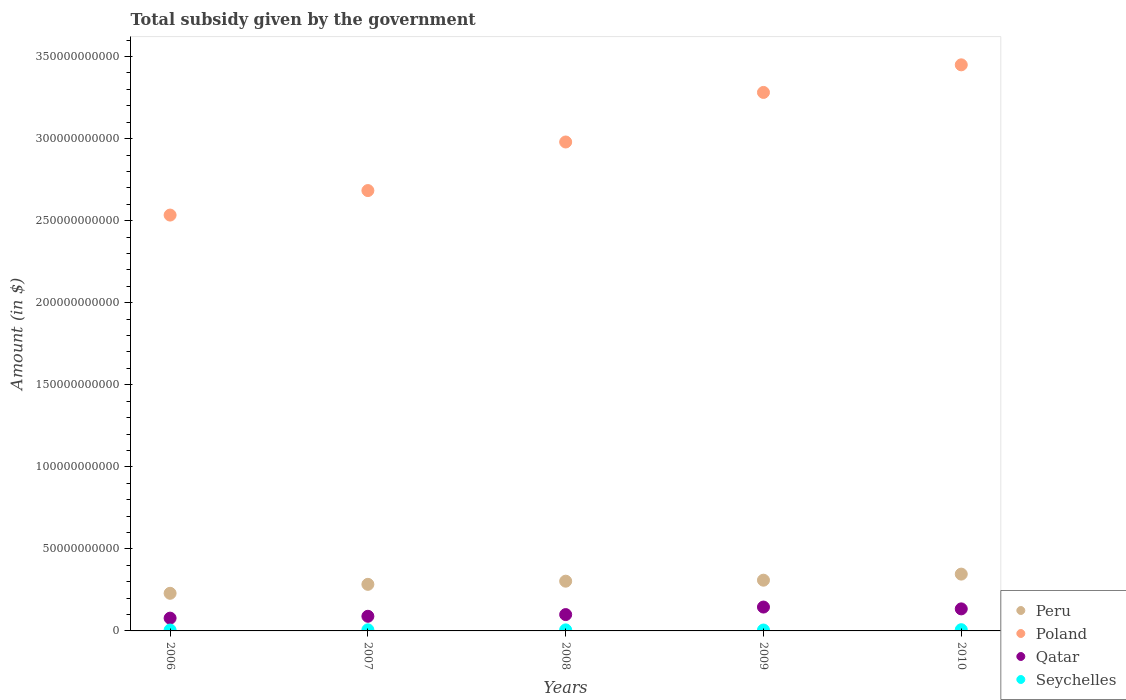How many different coloured dotlines are there?
Your response must be concise. 4. What is the total revenue collected by the government in Peru in 2007?
Your answer should be compact. 2.84e+1. Across all years, what is the maximum total revenue collected by the government in Qatar?
Your response must be concise. 1.45e+1. Across all years, what is the minimum total revenue collected by the government in Peru?
Ensure brevity in your answer.  2.29e+1. In which year was the total revenue collected by the government in Qatar minimum?
Provide a short and direct response. 2006. What is the total total revenue collected by the government in Poland in the graph?
Ensure brevity in your answer.  1.49e+12. What is the difference between the total revenue collected by the government in Peru in 2007 and that in 2010?
Give a very brief answer. -6.23e+09. What is the difference between the total revenue collected by the government in Qatar in 2010 and the total revenue collected by the government in Peru in 2007?
Keep it short and to the point. -1.50e+1. What is the average total revenue collected by the government in Seychelles per year?
Give a very brief answer. 6.26e+08. In the year 2007, what is the difference between the total revenue collected by the government in Seychelles and total revenue collected by the government in Peru?
Give a very brief answer. -2.77e+1. In how many years, is the total revenue collected by the government in Qatar greater than 340000000000 $?
Keep it short and to the point. 0. What is the ratio of the total revenue collected by the government in Qatar in 2009 to that in 2010?
Ensure brevity in your answer.  1.08. Is the difference between the total revenue collected by the government in Seychelles in 2006 and 2010 greater than the difference between the total revenue collected by the government in Peru in 2006 and 2010?
Give a very brief answer. Yes. What is the difference between the highest and the second highest total revenue collected by the government in Peru?
Give a very brief answer. 3.70e+09. What is the difference between the highest and the lowest total revenue collected by the government in Seychelles?
Ensure brevity in your answer.  2.07e+08. Is the sum of the total revenue collected by the government in Qatar in 2006 and 2008 greater than the maximum total revenue collected by the government in Poland across all years?
Provide a short and direct response. No. Is it the case that in every year, the sum of the total revenue collected by the government in Peru and total revenue collected by the government in Qatar  is greater than the total revenue collected by the government in Seychelles?
Offer a very short reply. Yes. Is the total revenue collected by the government in Qatar strictly greater than the total revenue collected by the government in Peru over the years?
Your response must be concise. No. Is the total revenue collected by the government in Qatar strictly less than the total revenue collected by the government in Seychelles over the years?
Provide a succinct answer. No. What is the difference between two consecutive major ticks on the Y-axis?
Offer a terse response. 5.00e+1. Does the graph contain any zero values?
Offer a very short reply. No. How many legend labels are there?
Keep it short and to the point. 4. How are the legend labels stacked?
Your response must be concise. Vertical. What is the title of the graph?
Keep it short and to the point. Total subsidy given by the government. Does "Costa Rica" appear as one of the legend labels in the graph?
Your response must be concise. No. What is the label or title of the Y-axis?
Give a very brief answer. Amount (in $). What is the Amount (in $) in Peru in 2006?
Offer a very short reply. 2.29e+1. What is the Amount (in $) in Poland in 2006?
Offer a very short reply. 2.53e+11. What is the Amount (in $) in Qatar in 2006?
Ensure brevity in your answer.  7.79e+09. What is the Amount (in $) of Seychelles in 2006?
Keep it short and to the point. 5.37e+08. What is the Amount (in $) in Peru in 2007?
Provide a short and direct response. 2.84e+1. What is the Amount (in $) of Poland in 2007?
Your answer should be compact. 2.68e+11. What is the Amount (in $) in Qatar in 2007?
Your response must be concise. 8.92e+09. What is the Amount (in $) in Seychelles in 2007?
Ensure brevity in your answer.  6.78e+08. What is the Amount (in $) in Peru in 2008?
Give a very brief answer. 3.03e+1. What is the Amount (in $) in Poland in 2008?
Offer a very short reply. 2.98e+11. What is the Amount (in $) in Qatar in 2008?
Offer a very short reply. 9.95e+09. What is the Amount (in $) of Seychelles in 2008?
Provide a short and direct response. 6.32e+08. What is the Amount (in $) in Peru in 2009?
Give a very brief answer. 3.09e+1. What is the Amount (in $) of Poland in 2009?
Your response must be concise. 3.28e+11. What is the Amount (in $) of Qatar in 2009?
Give a very brief answer. 1.45e+1. What is the Amount (in $) in Seychelles in 2009?
Offer a very short reply. 5.37e+08. What is the Amount (in $) of Peru in 2010?
Offer a very short reply. 3.46e+1. What is the Amount (in $) in Poland in 2010?
Provide a succinct answer. 3.45e+11. What is the Amount (in $) of Qatar in 2010?
Your answer should be compact. 1.34e+1. What is the Amount (in $) of Seychelles in 2010?
Provide a succinct answer. 7.44e+08. Across all years, what is the maximum Amount (in $) in Peru?
Your response must be concise. 3.46e+1. Across all years, what is the maximum Amount (in $) of Poland?
Provide a succinct answer. 3.45e+11. Across all years, what is the maximum Amount (in $) in Qatar?
Offer a very short reply. 1.45e+1. Across all years, what is the maximum Amount (in $) of Seychelles?
Your response must be concise. 7.44e+08. Across all years, what is the minimum Amount (in $) in Peru?
Your answer should be very brief. 2.29e+1. Across all years, what is the minimum Amount (in $) in Poland?
Provide a succinct answer. 2.53e+11. Across all years, what is the minimum Amount (in $) in Qatar?
Provide a succinct answer. 7.79e+09. Across all years, what is the minimum Amount (in $) of Seychelles?
Your response must be concise. 5.37e+08. What is the total Amount (in $) in Peru in the graph?
Your answer should be very brief. 1.47e+11. What is the total Amount (in $) of Poland in the graph?
Ensure brevity in your answer.  1.49e+12. What is the total Amount (in $) in Qatar in the graph?
Provide a succinct answer. 5.46e+1. What is the total Amount (in $) of Seychelles in the graph?
Keep it short and to the point. 3.13e+09. What is the difference between the Amount (in $) in Peru in 2006 and that in 2007?
Your answer should be very brief. -5.46e+09. What is the difference between the Amount (in $) of Poland in 2006 and that in 2007?
Keep it short and to the point. -1.49e+1. What is the difference between the Amount (in $) of Qatar in 2006 and that in 2007?
Give a very brief answer. -1.13e+09. What is the difference between the Amount (in $) in Seychelles in 2006 and that in 2007?
Provide a short and direct response. -1.41e+08. What is the difference between the Amount (in $) of Peru in 2006 and that in 2008?
Ensure brevity in your answer.  -7.38e+09. What is the difference between the Amount (in $) of Poland in 2006 and that in 2008?
Provide a short and direct response. -4.45e+1. What is the difference between the Amount (in $) in Qatar in 2006 and that in 2008?
Give a very brief answer. -2.16e+09. What is the difference between the Amount (in $) of Seychelles in 2006 and that in 2008?
Provide a succinct answer. -9.57e+07. What is the difference between the Amount (in $) in Peru in 2006 and that in 2009?
Your answer should be very brief. -7.99e+09. What is the difference between the Amount (in $) in Poland in 2006 and that in 2009?
Provide a succinct answer. -7.47e+1. What is the difference between the Amount (in $) of Qatar in 2006 and that in 2009?
Your answer should be very brief. -6.75e+09. What is the difference between the Amount (in $) of Seychelles in 2006 and that in 2009?
Ensure brevity in your answer.  -7.73e+05. What is the difference between the Amount (in $) in Peru in 2006 and that in 2010?
Your response must be concise. -1.17e+1. What is the difference between the Amount (in $) of Poland in 2006 and that in 2010?
Offer a very short reply. -9.16e+1. What is the difference between the Amount (in $) of Qatar in 2006 and that in 2010?
Offer a very short reply. -5.64e+09. What is the difference between the Amount (in $) of Seychelles in 2006 and that in 2010?
Provide a succinct answer. -2.07e+08. What is the difference between the Amount (in $) in Peru in 2007 and that in 2008?
Provide a succinct answer. -1.93e+09. What is the difference between the Amount (in $) in Poland in 2007 and that in 2008?
Keep it short and to the point. -2.96e+1. What is the difference between the Amount (in $) of Qatar in 2007 and that in 2008?
Offer a very short reply. -1.03e+09. What is the difference between the Amount (in $) of Seychelles in 2007 and that in 2008?
Make the answer very short. 4.56e+07. What is the difference between the Amount (in $) in Peru in 2007 and that in 2009?
Your answer should be compact. -2.53e+09. What is the difference between the Amount (in $) in Poland in 2007 and that in 2009?
Give a very brief answer. -5.98e+1. What is the difference between the Amount (in $) in Qatar in 2007 and that in 2009?
Your response must be concise. -5.62e+09. What is the difference between the Amount (in $) in Seychelles in 2007 and that in 2009?
Provide a short and direct response. 1.41e+08. What is the difference between the Amount (in $) of Peru in 2007 and that in 2010?
Your answer should be compact. -6.23e+09. What is the difference between the Amount (in $) in Poland in 2007 and that in 2010?
Offer a terse response. -7.66e+1. What is the difference between the Amount (in $) of Qatar in 2007 and that in 2010?
Ensure brevity in your answer.  -4.51e+09. What is the difference between the Amount (in $) in Seychelles in 2007 and that in 2010?
Offer a terse response. -6.58e+07. What is the difference between the Amount (in $) in Peru in 2008 and that in 2009?
Provide a succinct answer. -6.06e+08. What is the difference between the Amount (in $) of Poland in 2008 and that in 2009?
Provide a short and direct response. -3.02e+1. What is the difference between the Amount (in $) of Qatar in 2008 and that in 2009?
Give a very brief answer. -4.59e+09. What is the difference between the Amount (in $) of Seychelles in 2008 and that in 2009?
Keep it short and to the point. 9.50e+07. What is the difference between the Amount (in $) of Peru in 2008 and that in 2010?
Your answer should be compact. -4.31e+09. What is the difference between the Amount (in $) in Poland in 2008 and that in 2010?
Your answer should be very brief. -4.70e+1. What is the difference between the Amount (in $) in Qatar in 2008 and that in 2010?
Your answer should be very brief. -3.48e+09. What is the difference between the Amount (in $) in Seychelles in 2008 and that in 2010?
Ensure brevity in your answer.  -1.11e+08. What is the difference between the Amount (in $) of Peru in 2009 and that in 2010?
Offer a very short reply. -3.70e+09. What is the difference between the Amount (in $) of Poland in 2009 and that in 2010?
Make the answer very short. -1.68e+1. What is the difference between the Amount (in $) in Qatar in 2009 and that in 2010?
Ensure brevity in your answer.  1.11e+09. What is the difference between the Amount (in $) of Seychelles in 2009 and that in 2010?
Make the answer very short. -2.06e+08. What is the difference between the Amount (in $) of Peru in 2006 and the Amount (in $) of Poland in 2007?
Your response must be concise. -2.45e+11. What is the difference between the Amount (in $) of Peru in 2006 and the Amount (in $) of Qatar in 2007?
Your response must be concise. 1.40e+1. What is the difference between the Amount (in $) in Peru in 2006 and the Amount (in $) in Seychelles in 2007?
Make the answer very short. 2.22e+1. What is the difference between the Amount (in $) in Poland in 2006 and the Amount (in $) in Qatar in 2007?
Provide a short and direct response. 2.44e+11. What is the difference between the Amount (in $) in Poland in 2006 and the Amount (in $) in Seychelles in 2007?
Offer a terse response. 2.53e+11. What is the difference between the Amount (in $) in Qatar in 2006 and the Amount (in $) in Seychelles in 2007?
Provide a succinct answer. 7.11e+09. What is the difference between the Amount (in $) of Peru in 2006 and the Amount (in $) of Poland in 2008?
Your answer should be very brief. -2.75e+11. What is the difference between the Amount (in $) in Peru in 2006 and the Amount (in $) in Qatar in 2008?
Offer a terse response. 1.30e+1. What is the difference between the Amount (in $) in Peru in 2006 and the Amount (in $) in Seychelles in 2008?
Your answer should be compact. 2.23e+1. What is the difference between the Amount (in $) in Poland in 2006 and the Amount (in $) in Qatar in 2008?
Make the answer very short. 2.43e+11. What is the difference between the Amount (in $) of Poland in 2006 and the Amount (in $) of Seychelles in 2008?
Your answer should be very brief. 2.53e+11. What is the difference between the Amount (in $) in Qatar in 2006 and the Amount (in $) in Seychelles in 2008?
Keep it short and to the point. 7.16e+09. What is the difference between the Amount (in $) in Peru in 2006 and the Amount (in $) in Poland in 2009?
Your answer should be compact. -3.05e+11. What is the difference between the Amount (in $) in Peru in 2006 and the Amount (in $) in Qatar in 2009?
Provide a short and direct response. 8.39e+09. What is the difference between the Amount (in $) in Peru in 2006 and the Amount (in $) in Seychelles in 2009?
Give a very brief answer. 2.24e+1. What is the difference between the Amount (in $) of Poland in 2006 and the Amount (in $) of Qatar in 2009?
Your answer should be compact. 2.39e+11. What is the difference between the Amount (in $) in Poland in 2006 and the Amount (in $) in Seychelles in 2009?
Offer a very short reply. 2.53e+11. What is the difference between the Amount (in $) in Qatar in 2006 and the Amount (in $) in Seychelles in 2009?
Keep it short and to the point. 7.25e+09. What is the difference between the Amount (in $) of Peru in 2006 and the Amount (in $) of Poland in 2010?
Offer a terse response. -3.22e+11. What is the difference between the Amount (in $) of Peru in 2006 and the Amount (in $) of Qatar in 2010?
Ensure brevity in your answer.  9.49e+09. What is the difference between the Amount (in $) in Peru in 2006 and the Amount (in $) in Seychelles in 2010?
Give a very brief answer. 2.22e+1. What is the difference between the Amount (in $) of Poland in 2006 and the Amount (in $) of Qatar in 2010?
Your answer should be compact. 2.40e+11. What is the difference between the Amount (in $) of Poland in 2006 and the Amount (in $) of Seychelles in 2010?
Your answer should be compact. 2.53e+11. What is the difference between the Amount (in $) in Qatar in 2006 and the Amount (in $) in Seychelles in 2010?
Offer a very short reply. 7.04e+09. What is the difference between the Amount (in $) in Peru in 2007 and the Amount (in $) in Poland in 2008?
Your response must be concise. -2.70e+11. What is the difference between the Amount (in $) in Peru in 2007 and the Amount (in $) in Qatar in 2008?
Your answer should be compact. 1.84e+1. What is the difference between the Amount (in $) in Peru in 2007 and the Amount (in $) in Seychelles in 2008?
Make the answer very short. 2.78e+1. What is the difference between the Amount (in $) in Poland in 2007 and the Amount (in $) in Qatar in 2008?
Provide a succinct answer. 2.58e+11. What is the difference between the Amount (in $) of Poland in 2007 and the Amount (in $) of Seychelles in 2008?
Provide a succinct answer. 2.68e+11. What is the difference between the Amount (in $) in Qatar in 2007 and the Amount (in $) in Seychelles in 2008?
Offer a terse response. 8.29e+09. What is the difference between the Amount (in $) of Peru in 2007 and the Amount (in $) of Poland in 2009?
Make the answer very short. -3.00e+11. What is the difference between the Amount (in $) of Peru in 2007 and the Amount (in $) of Qatar in 2009?
Your answer should be very brief. 1.38e+1. What is the difference between the Amount (in $) in Peru in 2007 and the Amount (in $) in Seychelles in 2009?
Make the answer very short. 2.78e+1. What is the difference between the Amount (in $) in Poland in 2007 and the Amount (in $) in Qatar in 2009?
Offer a very short reply. 2.54e+11. What is the difference between the Amount (in $) in Poland in 2007 and the Amount (in $) in Seychelles in 2009?
Provide a short and direct response. 2.68e+11. What is the difference between the Amount (in $) in Qatar in 2007 and the Amount (in $) in Seychelles in 2009?
Offer a very short reply. 8.38e+09. What is the difference between the Amount (in $) of Peru in 2007 and the Amount (in $) of Poland in 2010?
Offer a very short reply. -3.17e+11. What is the difference between the Amount (in $) in Peru in 2007 and the Amount (in $) in Qatar in 2010?
Offer a very short reply. 1.50e+1. What is the difference between the Amount (in $) of Peru in 2007 and the Amount (in $) of Seychelles in 2010?
Your response must be concise. 2.76e+1. What is the difference between the Amount (in $) in Poland in 2007 and the Amount (in $) in Qatar in 2010?
Make the answer very short. 2.55e+11. What is the difference between the Amount (in $) in Poland in 2007 and the Amount (in $) in Seychelles in 2010?
Provide a short and direct response. 2.68e+11. What is the difference between the Amount (in $) in Qatar in 2007 and the Amount (in $) in Seychelles in 2010?
Provide a short and direct response. 8.18e+09. What is the difference between the Amount (in $) in Peru in 2008 and the Amount (in $) in Poland in 2009?
Make the answer very short. -2.98e+11. What is the difference between the Amount (in $) in Peru in 2008 and the Amount (in $) in Qatar in 2009?
Offer a very short reply. 1.58e+1. What is the difference between the Amount (in $) of Peru in 2008 and the Amount (in $) of Seychelles in 2009?
Offer a very short reply. 2.98e+1. What is the difference between the Amount (in $) in Poland in 2008 and the Amount (in $) in Qatar in 2009?
Provide a short and direct response. 2.83e+11. What is the difference between the Amount (in $) of Poland in 2008 and the Amount (in $) of Seychelles in 2009?
Ensure brevity in your answer.  2.97e+11. What is the difference between the Amount (in $) of Qatar in 2008 and the Amount (in $) of Seychelles in 2009?
Keep it short and to the point. 9.42e+09. What is the difference between the Amount (in $) of Peru in 2008 and the Amount (in $) of Poland in 2010?
Offer a very short reply. -3.15e+11. What is the difference between the Amount (in $) of Peru in 2008 and the Amount (in $) of Qatar in 2010?
Offer a very short reply. 1.69e+1. What is the difference between the Amount (in $) in Peru in 2008 and the Amount (in $) in Seychelles in 2010?
Make the answer very short. 2.96e+1. What is the difference between the Amount (in $) of Poland in 2008 and the Amount (in $) of Qatar in 2010?
Keep it short and to the point. 2.85e+11. What is the difference between the Amount (in $) in Poland in 2008 and the Amount (in $) in Seychelles in 2010?
Give a very brief answer. 2.97e+11. What is the difference between the Amount (in $) of Qatar in 2008 and the Amount (in $) of Seychelles in 2010?
Provide a succinct answer. 9.21e+09. What is the difference between the Amount (in $) of Peru in 2009 and the Amount (in $) of Poland in 2010?
Ensure brevity in your answer.  -3.14e+11. What is the difference between the Amount (in $) in Peru in 2009 and the Amount (in $) in Qatar in 2010?
Offer a very short reply. 1.75e+1. What is the difference between the Amount (in $) of Peru in 2009 and the Amount (in $) of Seychelles in 2010?
Ensure brevity in your answer.  3.02e+1. What is the difference between the Amount (in $) in Poland in 2009 and the Amount (in $) in Qatar in 2010?
Give a very brief answer. 3.15e+11. What is the difference between the Amount (in $) of Poland in 2009 and the Amount (in $) of Seychelles in 2010?
Offer a very short reply. 3.27e+11. What is the difference between the Amount (in $) of Qatar in 2009 and the Amount (in $) of Seychelles in 2010?
Your answer should be very brief. 1.38e+1. What is the average Amount (in $) in Peru per year?
Your response must be concise. 2.94e+1. What is the average Amount (in $) of Poland per year?
Offer a very short reply. 2.99e+11. What is the average Amount (in $) in Qatar per year?
Provide a short and direct response. 1.09e+1. What is the average Amount (in $) in Seychelles per year?
Your answer should be compact. 6.26e+08. In the year 2006, what is the difference between the Amount (in $) of Peru and Amount (in $) of Poland?
Give a very brief answer. -2.30e+11. In the year 2006, what is the difference between the Amount (in $) of Peru and Amount (in $) of Qatar?
Offer a terse response. 1.51e+1. In the year 2006, what is the difference between the Amount (in $) in Peru and Amount (in $) in Seychelles?
Your response must be concise. 2.24e+1. In the year 2006, what is the difference between the Amount (in $) of Poland and Amount (in $) of Qatar?
Your answer should be very brief. 2.46e+11. In the year 2006, what is the difference between the Amount (in $) in Poland and Amount (in $) in Seychelles?
Make the answer very short. 2.53e+11. In the year 2006, what is the difference between the Amount (in $) of Qatar and Amount (in $) of Seychelles?
Your answer should be very brief. 7.25e+09. In the year 2007, what is the difference between the Amount (in $) in Peru and Amount (in $) in Poland?
Ensure brevity in your answer.  -2.40e+11. In the year 2007, what is the difference between the Amount (in $) of Peru and Amount (in $) of Qatar?
Make the answer very short. 1.95e+1. In the year 2007, what is the difference between the Amount (in $) in Peru and Amount (in $) in Seychelles?
Ensure brevity in your answer.  2.77e+1. In the year 2007, what is the difference between the Amount (in $) in Poland and Amount (in $) in Qatar?
Your answer should be compact. 2.59e+11. In the year 2007, what is the difference between the Amount (in $) of Poland and Amount (in $) of Seychelles?
Your response must be concise. 2.68e+11. In the year 2007, what is the difference between the Amount (in $) of Qatar and Amount (in $) of Seychelles?
Offer a terse response. 8.24e+09. In the year 2008, what is the difference between the Amount (in $) of Peru and Amount (in $) of Poland?
Your response must be concise. -2.68e+11. In the year 2008, what is the difference between the Amount (in $) of Peru and Amount (in $) of Qatar?
Your response must be concise. 2.04e+1. In the year 2008, what is the difference between the Amount (in $) in Peru and Amount (in $) in Seychelles?
Your answer should be compact. 2.97e+1. In the year 2008, what is the difference between the Amount (in $) of Poland and Amount (in $) of Qatar?
Your answer should be very brief. 2.88e+11. In the year 2008, what is the difference between the Amount (in $) of Poland and Amount (in $) of Seychelles?
Offer a terse response. 2.97e+11. In the year 2008, what is the difference between the Amount (in $) in Qatar and Amount (in $) in Seychelles?
Your answer should be very brief. 9.32e+09. In the year 2009, what is the difference between the Amount (in $) of Peru and Amount (in $) of Poland?
Offer a very short reply. -2.97e+11. In the year 2009, what is the difference between the Amount (in $) in Peru and Amount (in $) in Qatar?
Provide a succinct answer. 1.64e+1. In the year 2009, what is the difference between the Amount (in $) in Peru and Amount (in $) in Seychelles?
Offer a very short reply. 3.04e+1. In the year 2009, what is the difference between the Amount (in $) of Poland and Amount (in $) of Qatar?
Ensure brevity in your answer.  3.14e+11. In the year 2009, what is the difference between the Amount (in $) of Poland and Amount (in $) of Seychelles?
Keep it short and to the point. 3.28e+11. In the year 2009, what is the difference between the Amount (in $) in Qatar and Amount (in $) in Seychelles?
Keep it short and to the point. 1.40e+1. In the year 2010, what is the difference between the Amount (in $) in Peru and Amount (in $) in Poland?
Provide a succinct answer. -3.10e+11. In the year 2010, what is the difference between the Amount (in $) of Peru and Amount (in $) of Qatar?
Your answer should be compact. 2.12e+1. In the year 2010, what is the difference between the Amount (in $) in Peru and Amount (in $) in Seychelles?
Offer a terse response. 3.39e+1. In the year 2010, what is the difference between the Amount (in $) of Poland and Amount (in $) of Qatar?
Your response must be concise. 3.32e+11. In the year 2010, what is the difference between the Amount (in $) in Poland and Amount (in $) in Seychelles?
Provide a succinct answer. 3.44e+11. In the year 2010, what is the difference between the Amount (in $) in Qatar and Amount (in $) in Seychelles?
Provide a short and direct response. 1.27e+1. What is the ratio of the Amount (in $) in Peru in 2006 to that in 2007?
Offer a very short reply. 0.81. What is the ratio of the Amount (in $) in Poland in 2006 to that in 2007?
Your answer should be very brief. 0.94. What is the ratio of the Amount (in $) in Qatar in 2006 to that in 2007?
Give a very brief answer. 0.87. What is the ratio of the Amount (in $) in Seychelles in 2006 to that in 2007?
Your answer should be compact. 0.79. What is the ratio of the Amount (in $) of Peru in 2006 to that in 2008?
Offer a terse response. 0.76. What is the ratio of the Amount (in $) of Poland in 2006 to that in 2008?
Offer a very short reply. 0.85. What is the ratio of the Amount (in $) of Qatar in 2006 to that in 2008?
Your answer should be compact. 0.78. What is the ratio of the Amount (in $) of Seychelles in 2006 to that in 2008?
Your response must be concise. 0.85. What is the ratio of the Amount (in $) of Peru in 2006 to that in 2009?
Offer a terse response. 0.74. What is the ratio of the Amount (in $) of Poland in 2006 to that in 2009?
Ensure brevity in your answer.  0.77. What is the ratio of the Amount (in $) in Qatar in 2006 to that in 2009?
Provide a short and direct response. 0.54. What is the ratio of the Amount (in $) in Seychelles in 2006 to that in 2009?
Offer a very short reply. 1. What is the ratio of the Amount (in $) of Peru in 2006 to that in 2010?
Give a very brief answer. 0.66. What is the ratio of the Amount (in $) of Poland in 2006 to that in 2010?
Provide a short and direct response. 0.73. What is the ratio of the Amount (in $) in Qatar in 2006 to that in 2010?
Ensure brevity in your answer.  0.58. What is the ratio of the Amount (in $) of Seychelles in 2006 to that in 2010?
Give a very brief answer. 0.72. What is the ratio of the Amount (in $) of Peru in 2007 to that in 2008?
Provide a short and direct response. 0.94. What is the ratio of the Amount (in $) of Poland in 2007 to that in 2008?
Provide a succinct answer. 0.9. What is the ratio of the Amount (in $) in Qatar in 2007 to that in 2008?
Give a very brief answer. 0.9. What is the ratio of the Amount (in $) in Seychelles in 2007 to that in 2008?
Keep it short and to the point. 1.07. What is the ratio of the Amount (in $) in Peru in 2007 to that in 2009?
Your response must be concise. 0.92. What is the ratio of the Amount (in $) of Poland in 2007 to that in 2009?
Provide a short and direct response. 0.82. What is the ratio of the Amount (in $) of Qatar in 2007 to that in 2009?
Provide a short and direct response. 0.61. What is the ratio of the Amount (in $) of Seychelles in 2007 to that in 2009?
Ensure brevity in your answer.  1.26. What is the ratio of the Amount (in $) in Peru in 2007 to that in 2010?
Provide a succinct answer. 0.82. What is the ratio of the Amount (in $) of Poland in 2007 to that in 2010?
Provide a succinct answer. 0.78. What is the ratio of the Amount (in $) in Qatar in 2007 to that in 2010?
Offer a very short reply. 0.66. What is the ratio of the Amount (in $) of Seychelles in 2007 to that in 2010?
Offer a terse response. 0.91. What is the ratio of the Amount (in $) of Peru in 2008 to that in 2009?
Provide a succinct answer. 0.98. What is the ratio of the Amount (in $) in Poland in 2008 to that in 2009?
Your response must be concise. 0.91. What is the ratio of the Amount (in $) of Qatar in 2008 to that in 2009?
Your answer should be very brief. 0.68. What is the ratio of the Amount (in $) of Seychelles in 2008 to that in 2009?
Make the answer very short. 1.18. What is the ratio of the Amount (in $) of Peru in 2008 to that in 2010?
Make the answer very short. 0.88. What is the ratio of the Amount (in $) of Poland in 2008 to that in 2010?
Make the answer very short. 0.86. What is the ratio of the Amount (in $) of Qatar in 2008 to that in 2010?
Your response must be concise. 0.74. What is the ratio of the Amount (in $) in Seychelles in 2008 to that in 2010?
Provide a succinct answer. 0.85. What is the ratio of the Amount (in $) of Peru in 2009 to that in 2010?
Ensure brevity in your answer.  0.89. What is the ratio of the Amount (in $) in Poland in 2009 to that in 2010?
Provide a short and direct response. 0.95. What is the ratio of the Amount (in $) in Qatar in 2009 to that in 2010?
Provide a short and direct response. 1.08. What is the ratio of the Amount (in $) of Seychelles in 2009 to that in 2010?
Your answer should be very brief. 0.72. What is the difference between the highest and the second highest Amount (in $) of Peru?
Ensure brevity in your answer.  3.70e+09. What is the difference between the highest and the second highest Amount (in $) of Poland?
Your answer should be very brief. 1.68e+1. What is the difference between the highest and the second highest Amount (in $) of Qatar?
Provide a short and direct response. 1.11e+09. What is the difference between the highest and the second highest Amount (in $) of Seychelles?
Give a very brief answer. 6.58e+07. What is the difference between the highest and the lowest Amount (in $) in Peru?
Make the answer very short. 1.17e+1. What is the difference between the highest and the lowest Amount (in $) of Poland?
Your response must be concise. 9.16e+1. What is the difference between the highest and the lowest Amount (in $) in Qatar?
Offer a very short reply. 6.75e+09. What is the difference between the highest and the lowest Amount (in $) of Seychelles?
Offer a very short reply. 2.07e+08. 